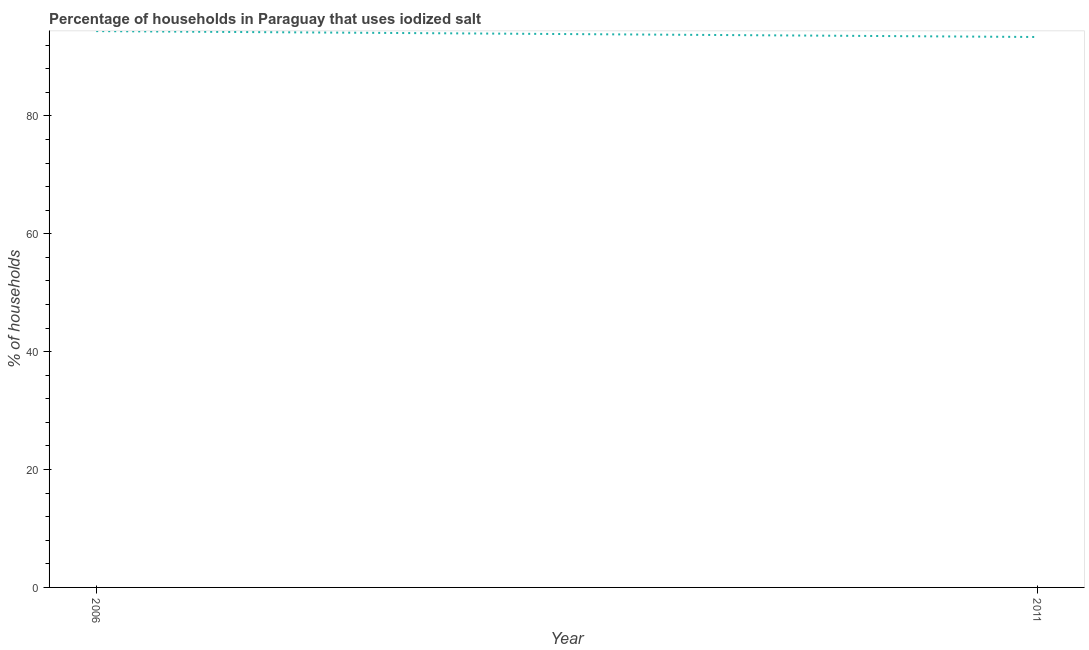What is the percentage of households where iodized salt is consumed in 2011?
Keep it short and to the point. 93.4. Across all years, what is the maximum percentage of households where iodized salt is consumed?
Give a very brief answer. 94.4. Across all years, what is the minimum percentage of households where iodized salt is consumed?
Your answer should be compact. 93.4. In which year was the percentage of households where iodized salt is consumed maximum?
Your answer should be compact. 2006. In which year was the percentage of households where iodized salt is consumed minimum?
Offer a very short reply. 2011. What is the sum of the percentage of households where iodized salt is consumed?
Keep it short and to the point. 187.8. What is the difference between the percentage of households where iodized salt is consumed in 2006 and 2011?
Your response must be concise. 1. What is the average percentage of households where iodized salt is consumed per year?
Ensure brevity in your answer.  93.9. What is the median percentage of households where iodized salt is consumed?
Your answer should be compact. 93.9. What is the ratio of the percentage of households where iodized salt is consumed in 2006 to that in 2011?
Give a very brief answer. 1.01. Is the percentage of households where iodized salt is consumed in 2006 less than that in 2011?
Your answer should be compact. No. How many lines are there?
Give a very brief answer. 1. How many years are there in the graph?
Your answer should be compact. 2. What is the difference between two consecutive major ticks on the Y-axis?
Provide a short and direct response. 20. Are the values on the major ticks of Y-axis written in scientific E-notation?
Ensure brevity in your answer.  No. Does the graph contain any zero values?
Offer a terse response. No. What is the title of the graph?
Your response must be concise. Percentage of households in Paraguay that uses iodized salt. What is the label or title of the Y-axis?
Your answer should be very brief. % of households. What is the % of households of 2006?
Provide a short and direct response. 94.4. What is the % of households of 2011?
Your answer should be compact. 93.4. What is the difference between the % of households in 2006 and 2011?
Your answer should be very brief. 1. 